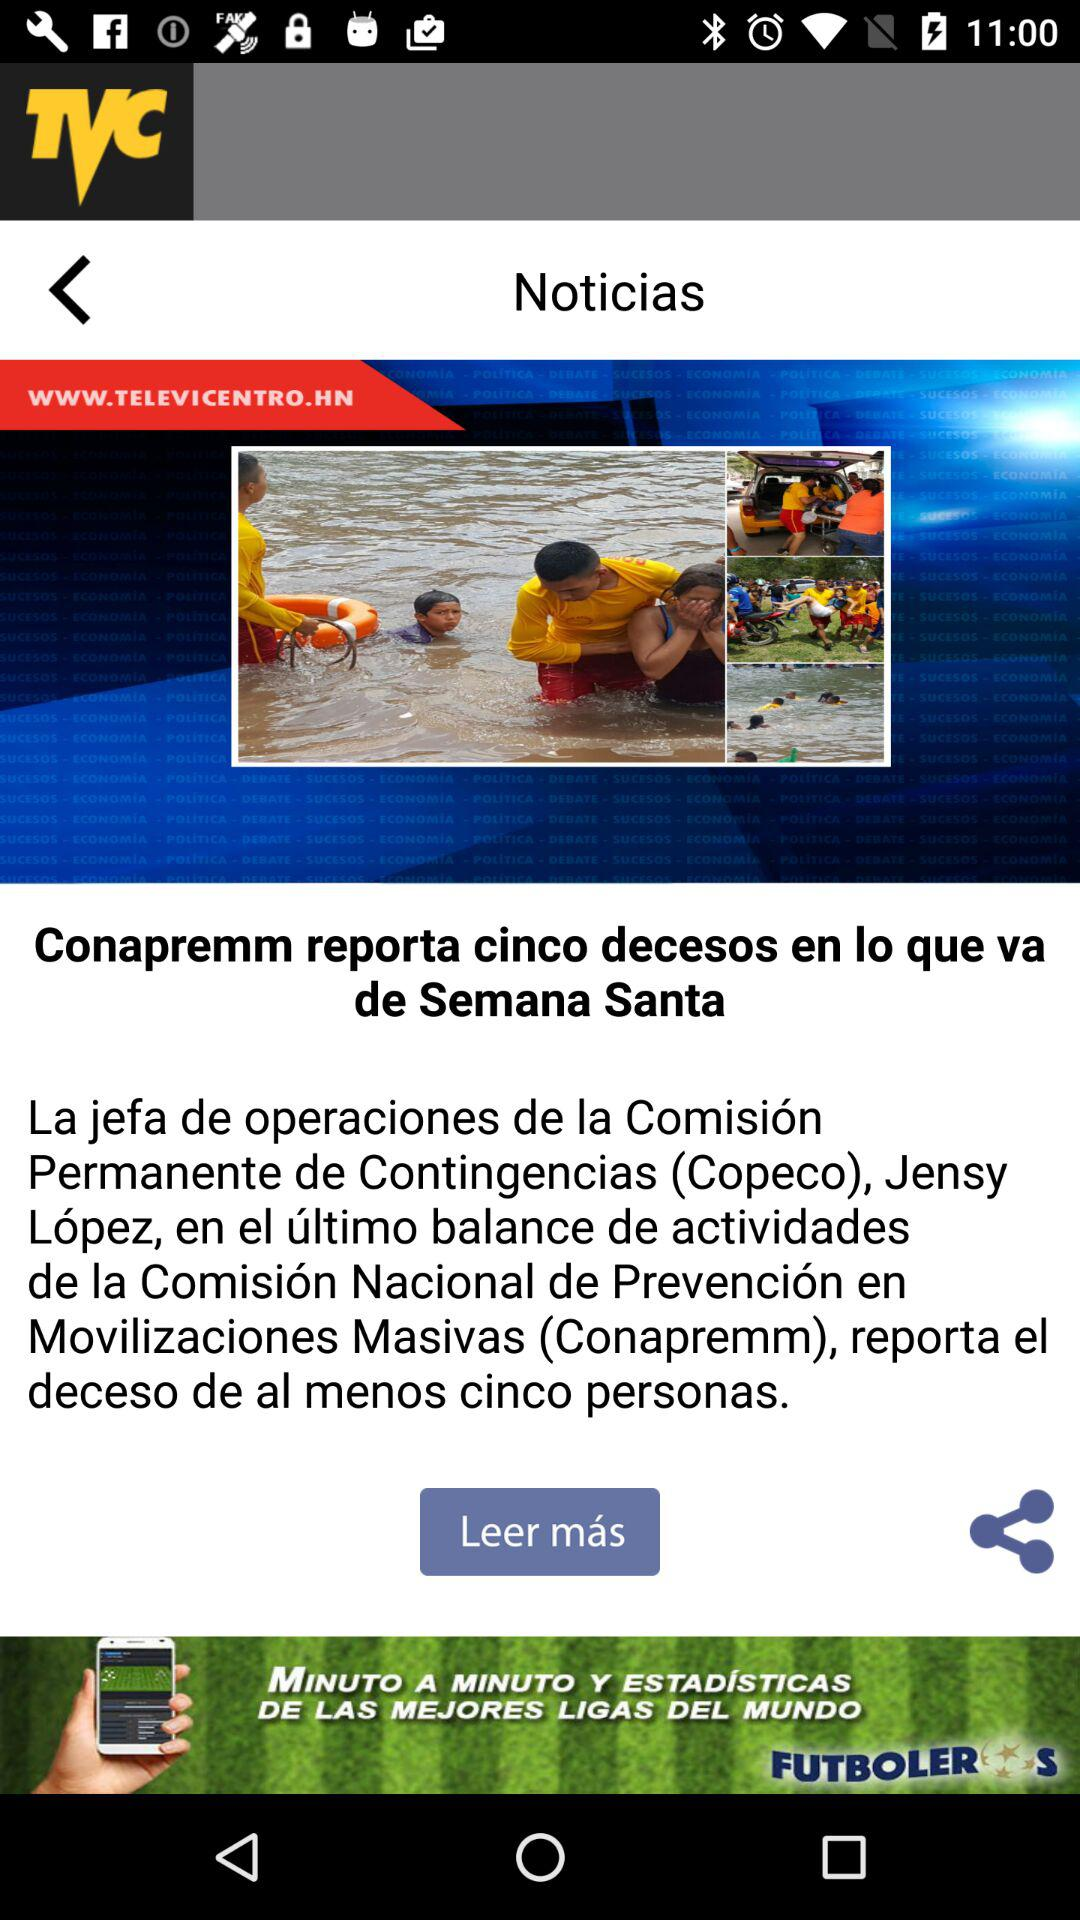What is the application name? The application name is "Televicentro". 